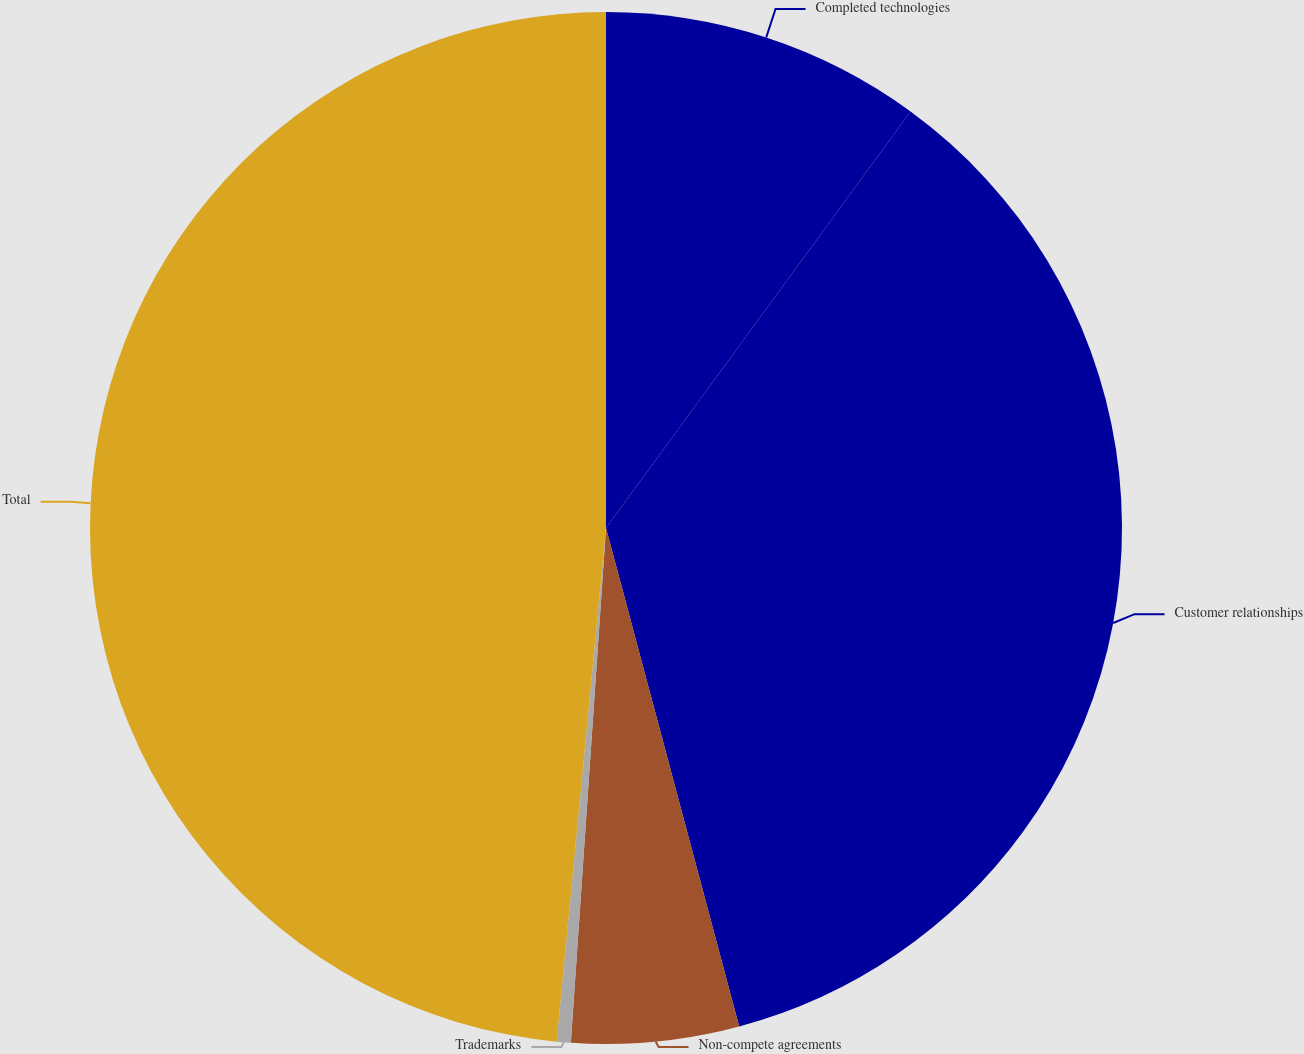<chart> <loc_0><loc_0><loc_500><loc_500><pie_chart><fcel>Completed technologies<fcel>Customer relationships<fcel>Non-compete agreements<fcel>Trademarks<fcel>Total<nl><fcel>10.05%<fcel>35.8%<fcel>5.24%<fcel>0.44%<fcel>48.48%<nl></chart> 